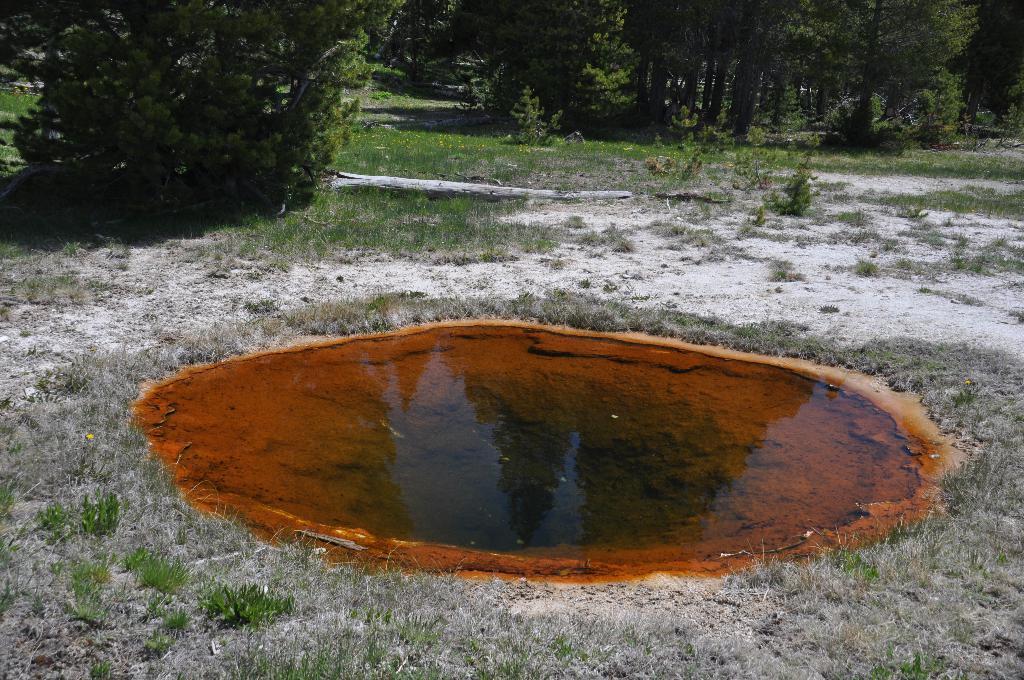In one or two sentences, can you explain what this image depicts? There is water in a grassy land as we can see at the bottom of this image, and there are some trees at the top of this image. 